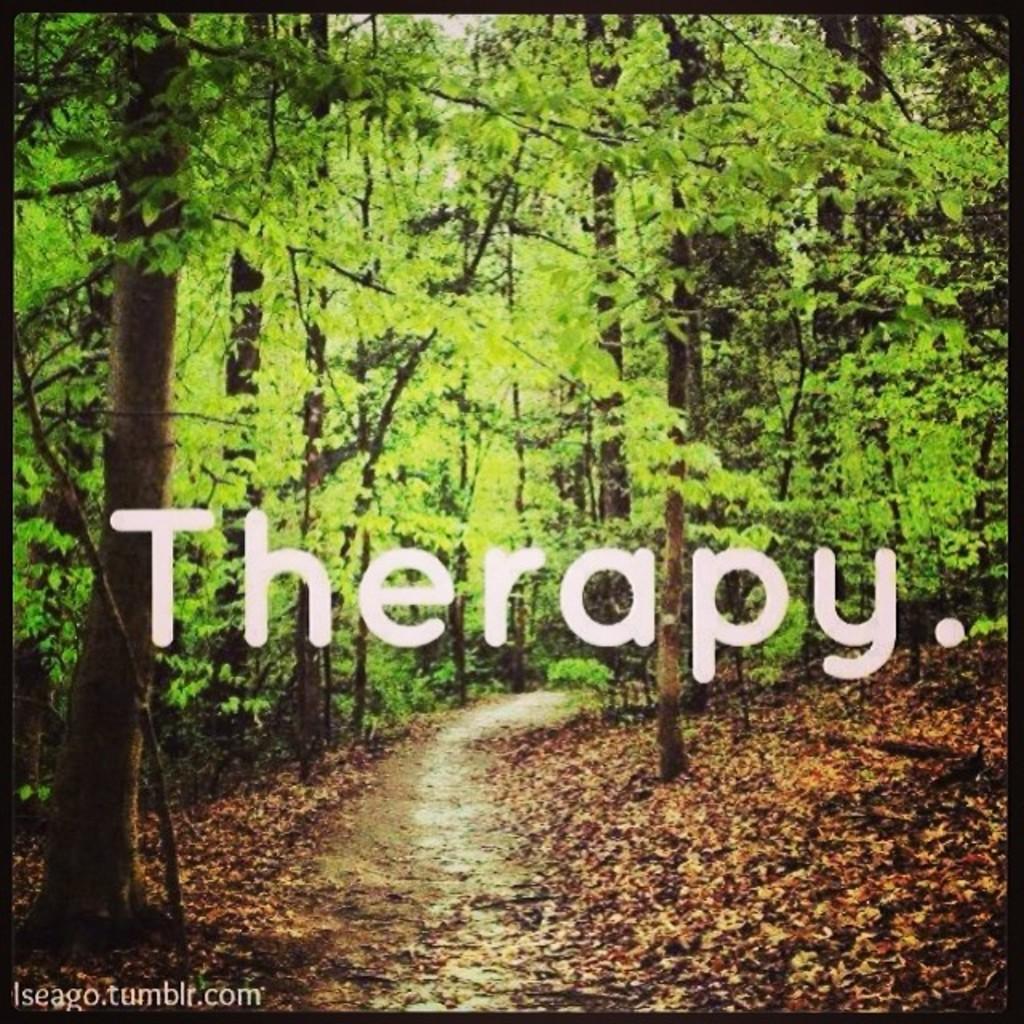How would you summarize this image in a sentence or two? In the picture I can see trees, a path and leaves on the ground. I can also see watermarks on the image. 